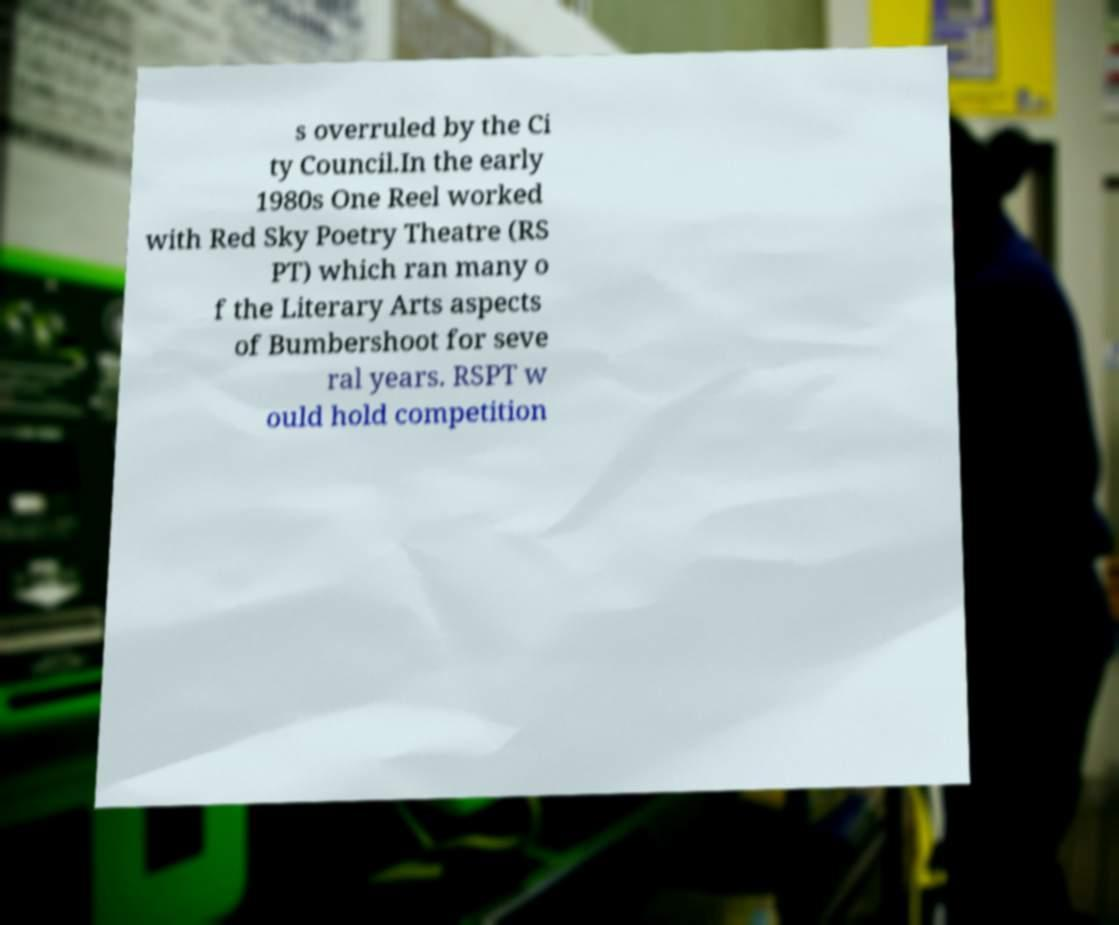For documentation purposes, I need the text within this image transcribed. Could you provide that? s overruled by the Ci ty Council.In the early 1980s One Reel worked with Red Sky Poetry Theatre (RS PT) which ran many o f the Literary Arts aspects of Bumbershoot for seve ral years. RSPT w ould hold competition 